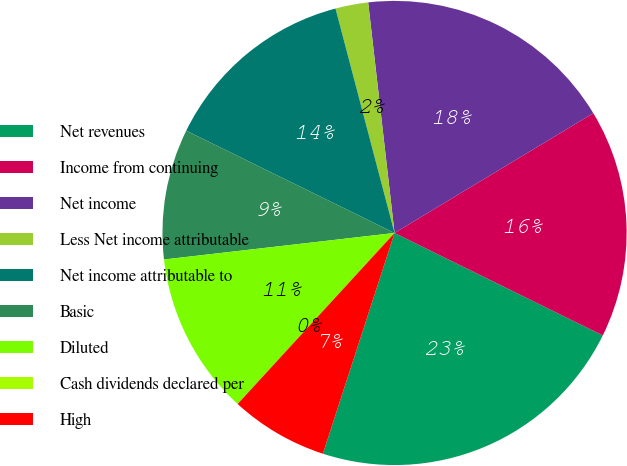<chart> <loc_0><loc_0><loc_500><loc_500><pie_chart><fcel>Net revenues<fcel>Income from continuing<fcel>Net income<fcel>Less Net income attributable<fcel>Net income attributable to<fcel>Basic<fcel>Diluted<fcel>Cash dividends declared per<fcel>High<nl><fcel>22.72%<fcel>15.91%<fcel>18.18%<fcel>2.28%<fcel>13.64%<fcel>9.09%<fcel>11.36%<fcel>0.0%<fcel>6.82%<nl></chart> 